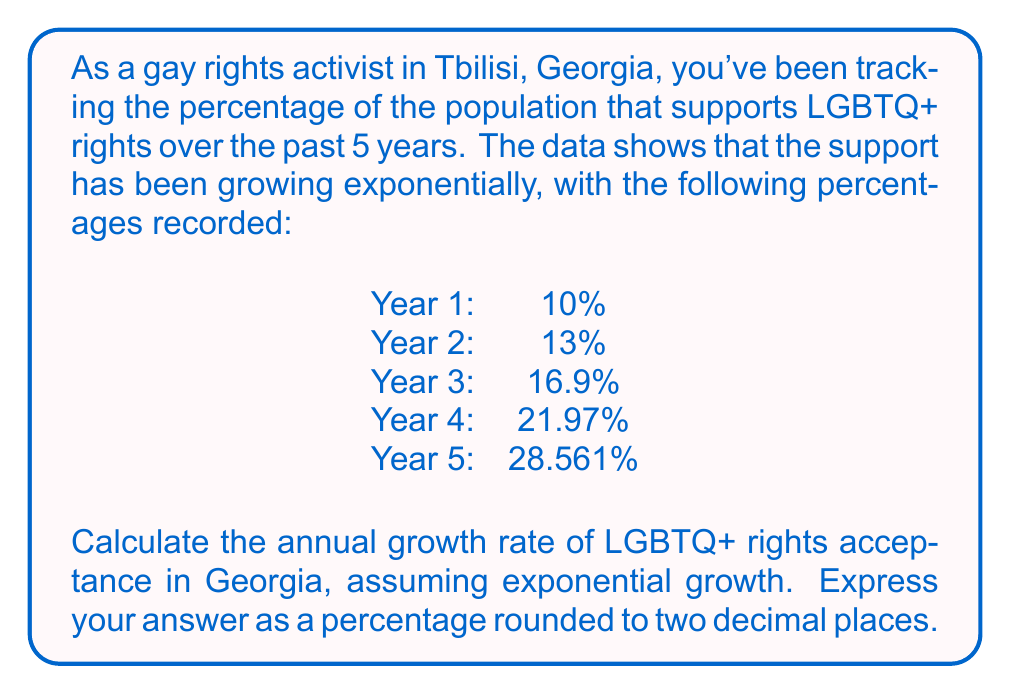Show me your answer to this math problem. To solve this problem, we'll use the exponential growth formula:

$$ A = P(1 + r)^t $$

Where:
$A$ is the final amount
$P$ is the initial amount
$r$ is the growth rate
$t$ is the time period

We know that:
$P = 10\%$ (initial percentage in Year 1)
$A = 28.561\%$ (final percentage in Year 5)
$t = 4$ (number of years between Year 1 and Year 5)

Let's substitute these values into the formula:

$$ 28.561 = 10(1 + r)^4 $$

To solve for $r$, we'll follow these steps:

1) Divide both sides by 10:
   $$ 2.8561 = (1 + r)^4 $$

2) Take the fourth root of both sides:
   $$ \sqrt[4]{2.8561} = 1 + r $$

3) Subtract 1 from both sides:
   $$ \sqrt[4]{2.8561} - 1 = r $$

4) Calculate the value:
   $$ r = 1.2997 - 1 = 0.2997 $$

5) Convert to a percentage:
   $$ r = 0.2997 \times 100\% = 29.97\% $$

6) Round to two decimal places:
   $$ r \approx 29.97\% $$
Answer: The annual growth rate of LGBTQ+ rights acceptance in Georgia is approximately 29.97%. 